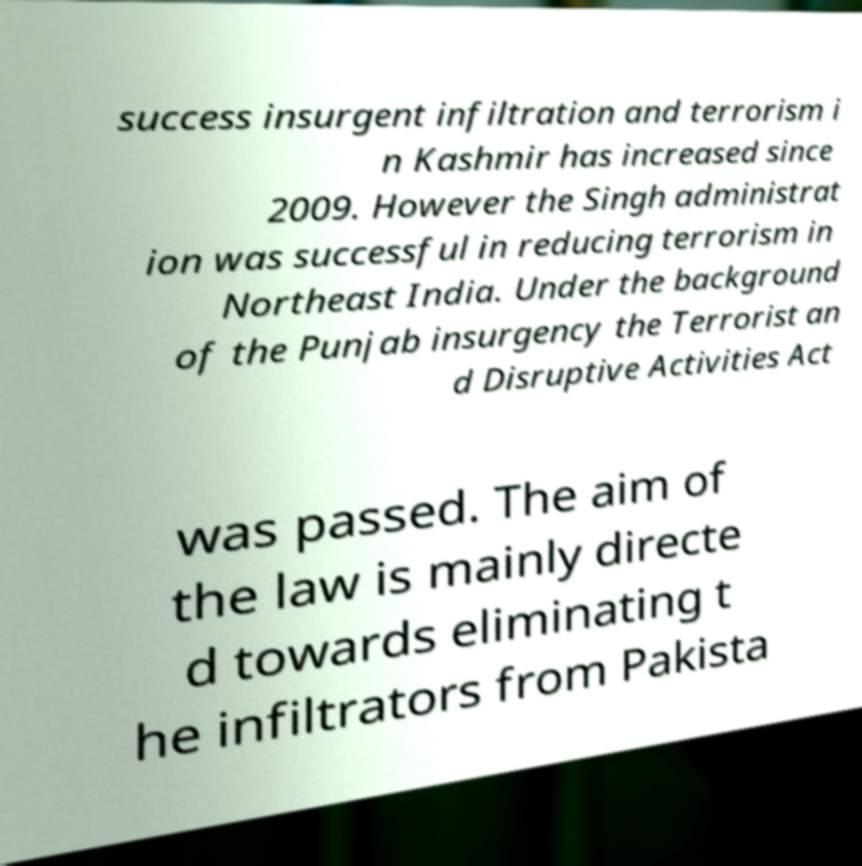Could you extract and type out the text from this image? success insurgent infiltration and terrorism i n Kashmir has increased since 2009. However the Singh administrat ion was successful in reducing terrorism in Northeast India. Under the background of the Punjab insurgency the Terrorist an d Disruptive Activities Act was passed. The aim of the law is mainly directe d towards eliminating t he infiltrators from Pakista 